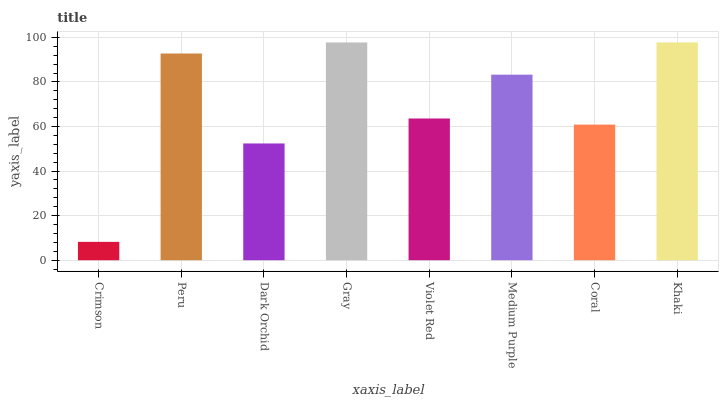Is Crimson the minimum?
Answer yes or no. Yes. Is Khaki the maximum?
Answer yes or no. Yes. Is Peru the minimum?
Answer yes or no. No. Is Peru the maximum?
Answer yes or no. No. Is Peru greater than Crimson?
Answer yes or no. Yes. Is Crimson less than Peru?
Answer yes or no. Yes. Is Crimson greater than Peru?
Answer yes or no. No. Is Peru less than Crimson?
Answer yes or no. No. Is Medium Purple the high median?
Answer yes or no. Yes. Is Violet Red the low median?
Answer yes or no. Yes. Is Crimson the high median?
Answer yes or no. No. Is Crimson the low median?
Answer yes or no. No. 